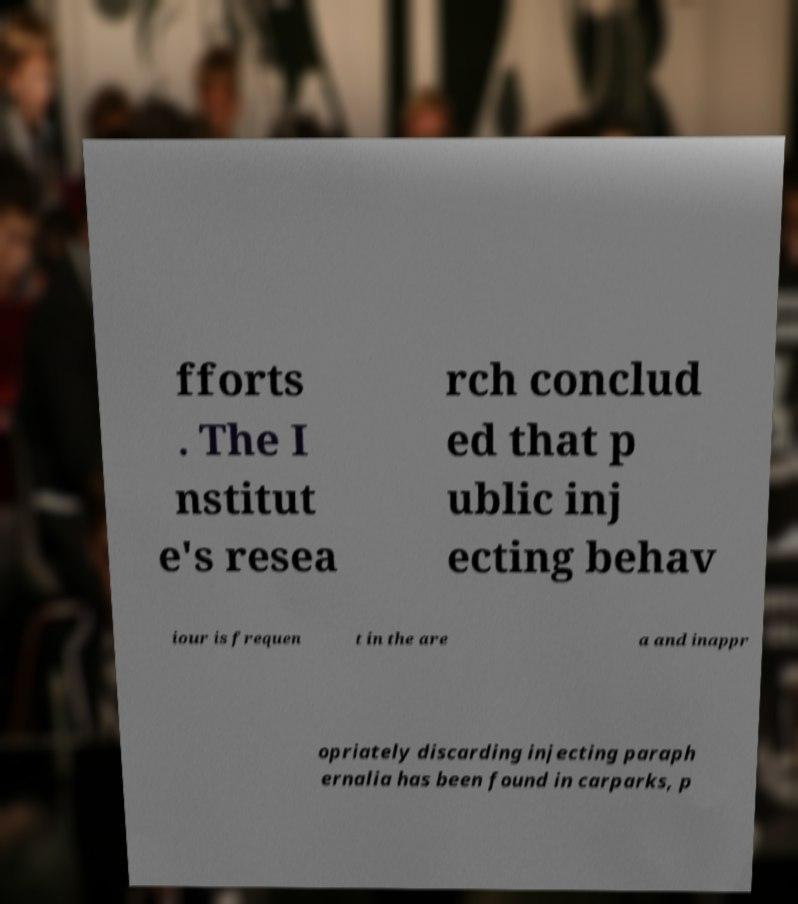There's text embedded in this image that I need extracted. Can you transcribe it verbatim? fforts . The I nstitut e's resea rch conclud ed that p ublic inj ecting behav iour is frequen t in the are a and inappr opriately discarding injecting paraph ernalia has been found in carparks, p 